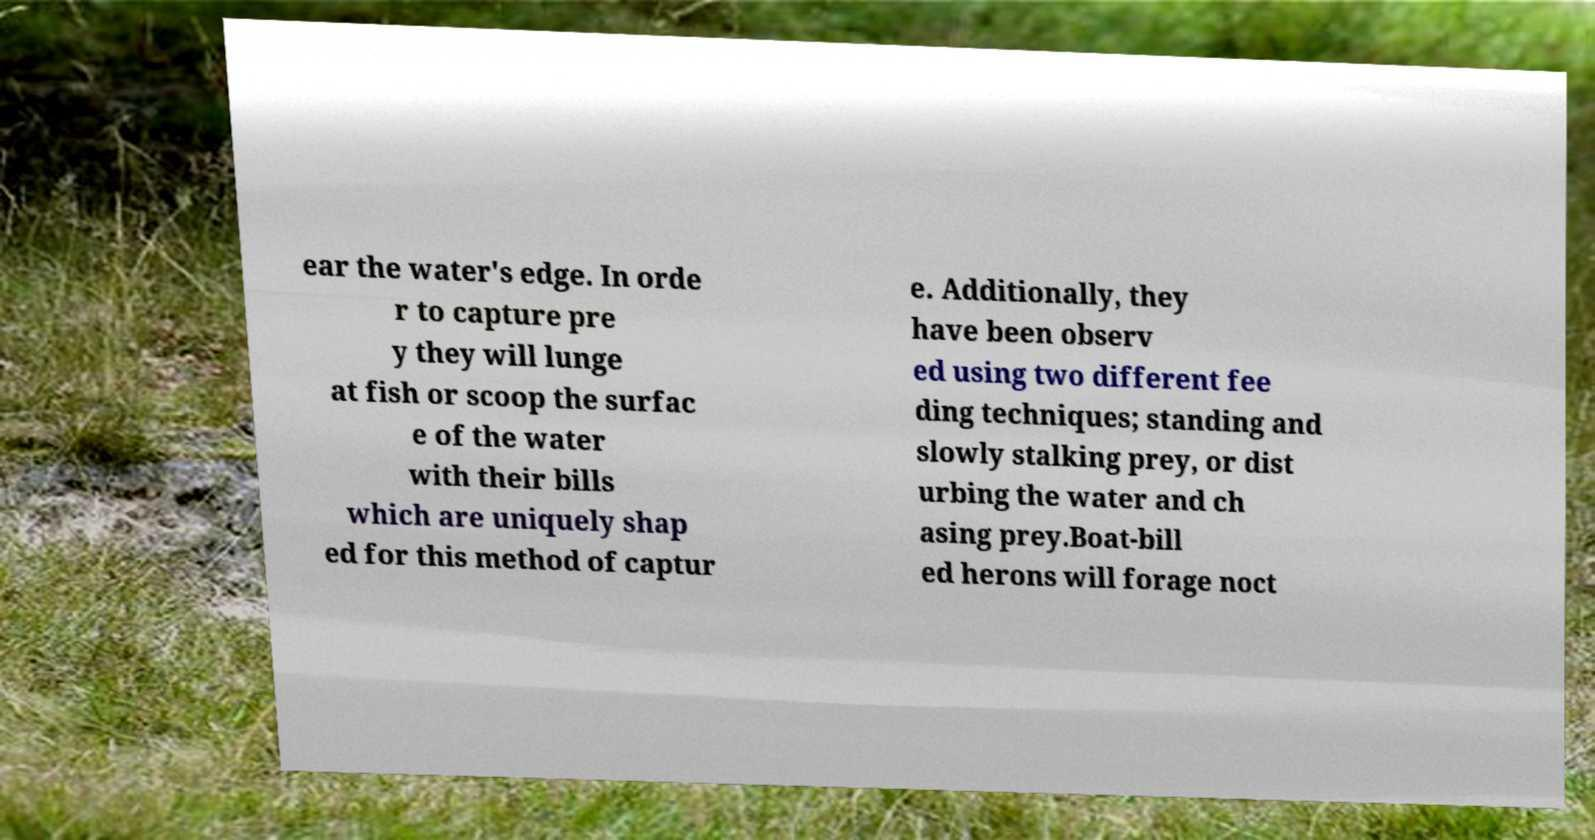Can you read and provide the text displayed in the image?This photo seems to have some interesting text. Can you extract and type it out for me? ear the water's edge. In orde r to capture pre y they will lunge at fish or scoop the surfac e of the water with their bills which are uniquely shap ed for this method of captur e. Additionally, they have been observ ed using two different fee ding techniques; standing and slowly stalking prey, or dist urbing the water and ch asing prey.Boat-bill ed herons will forage noct 